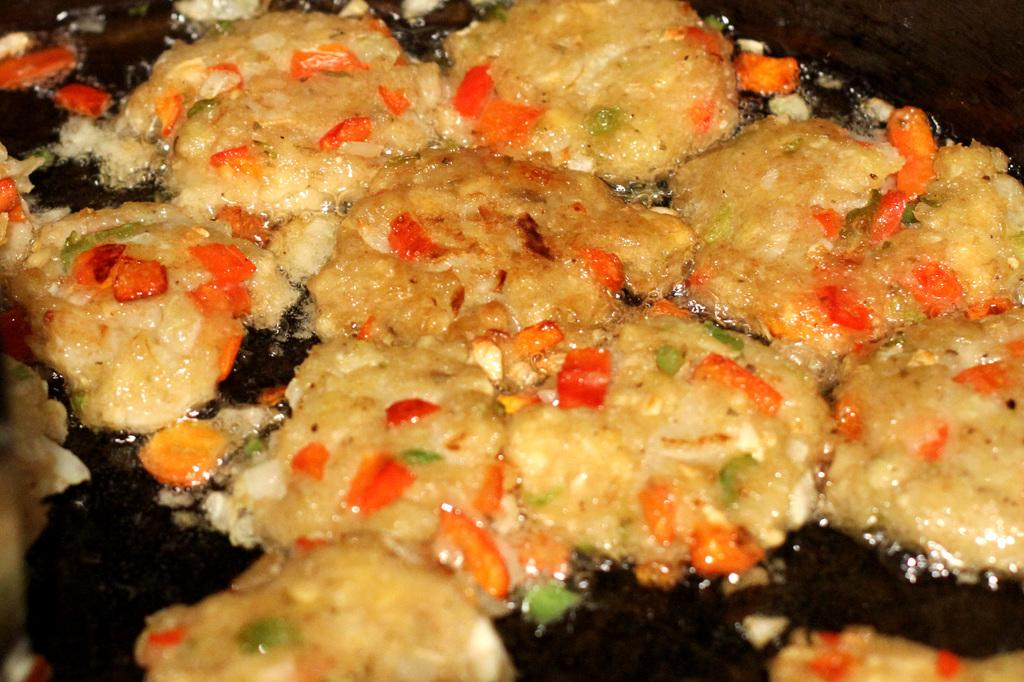What type of items can be seen in the image? There are food items in the image. How are the food items prepared or presented? The food items are in oil. What type of collar is visible on the food items in the image? There is no collar present on the food items in the image. 